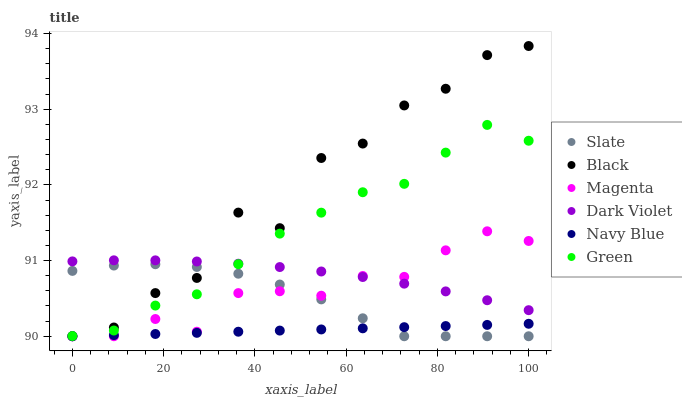Does Navy Blue have the minimum area under the curve?
Answer yes or no. Yes. Does Black have the maximum area under the curve?
Answer yes or no. Yes. Does Slate have the minimum area under the curve?
Answer yes or no. No. Does Slate have the maximum area under the curve?
Answer yes or no. No. Is Navy Blue the smoothest?
Answer yes or no. Yes. Is Black the roughest?
Answer yes or no. Yes. Is Slate the smoothest?
Answer yes or no. No. Is Slate the roughest?
Answer yes or no. No. Does Navy Blue have the lowest value?
Answer yes or no. Yes. Does Dark Violet have the lowest value?
Answer yes or no. No. Does Black have the highest value?
Answer yes or no. Yes. Does Slate have the highest value?
Answer yes or no. No. Is Navy Blue less than Dark Violet?
Answer yes or no. Yes. Is Green greater than Navy Blue?
Answer yes or no. Yes. Does Black intersect Dark Violet?
Answer yes or no. Yes. Is Black less than Dark Violet?
Answer yes or no. No. Is Black greater than Dark Violet?
Answer yes or no. No. Does Navy Blue intersect Dark Violet?
Answer yes or no. No. 